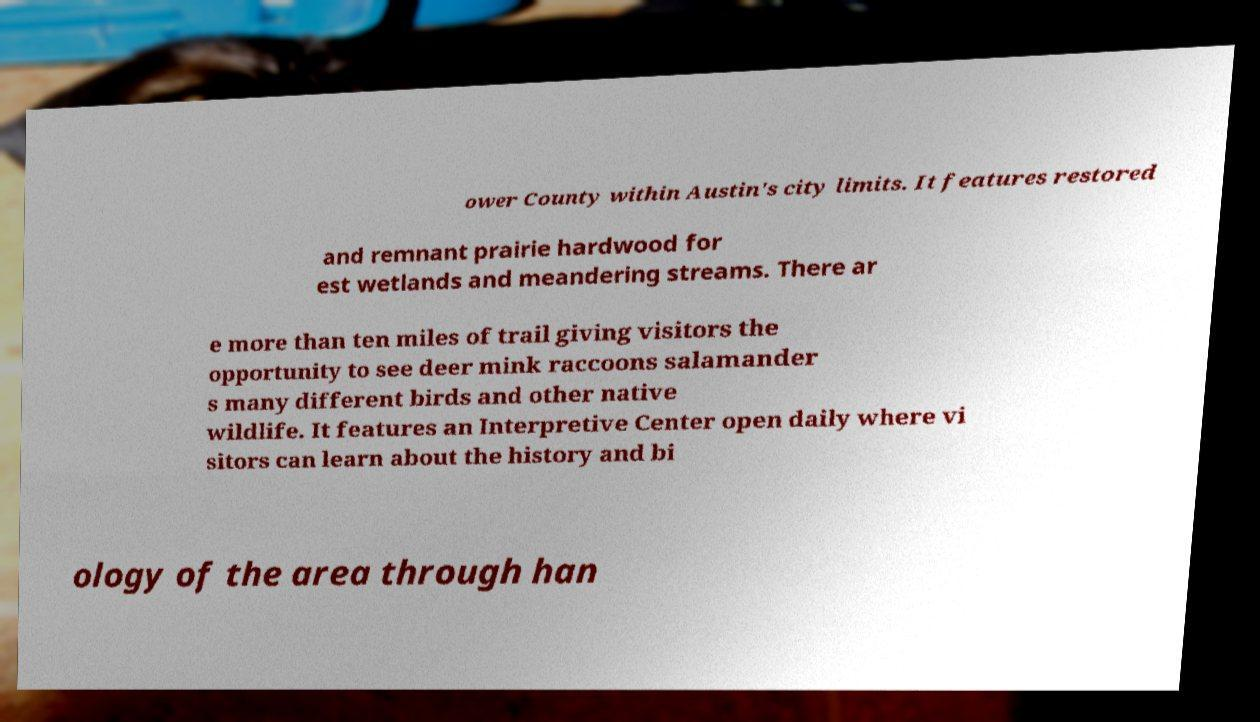What messages or text are displayed in this image? I need them in a readable, typed format. ower County within Austin's city limits. It features restored and remnant prairie hardwood for est wetlands and meandering streams. There ar e more than ten miles of trail giving visitors the opportunity to see deer mink raccoons salamander s many different birds and other native wildlife. It features an Interpretive Center open daily where vi sitors can learn about the history and bi ology of the area through han 